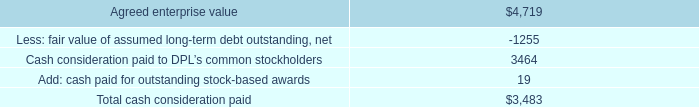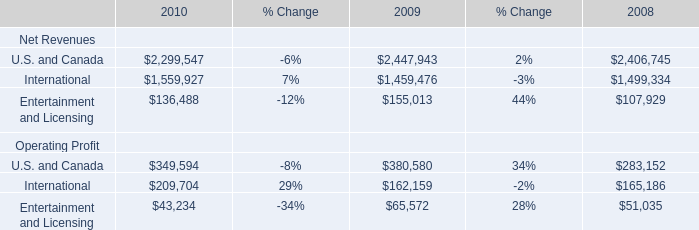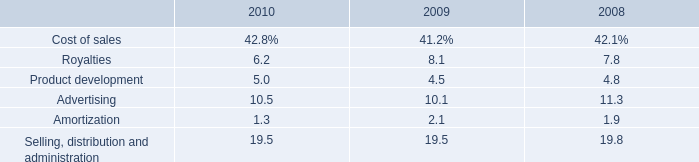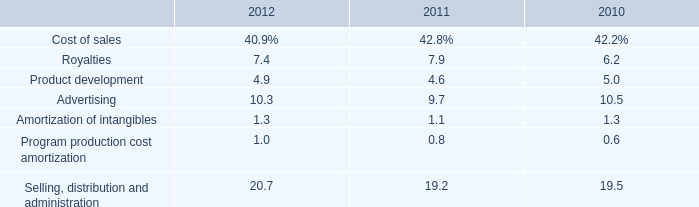What's the total amount of the Entertainment and Licensing for Net Revenues in the years where Product development is greater than 0? 
Computations: ((136488 + 155013) + 107929)
Answer: 399430.0. 